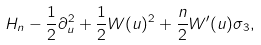Convert formula to latex. <formula><loc_0><loc_0><loc_500><loc_500>H _ { n } - \frac { 1 } { 2 } \partial _ { u } ^ { 2 } + \frac { 1 } { 2 } W ( u ) ^ { 2 } + \frac { n } { 2 } W ^ { \prime } ( u ) \sigma _ { 3 } ,</formula> 